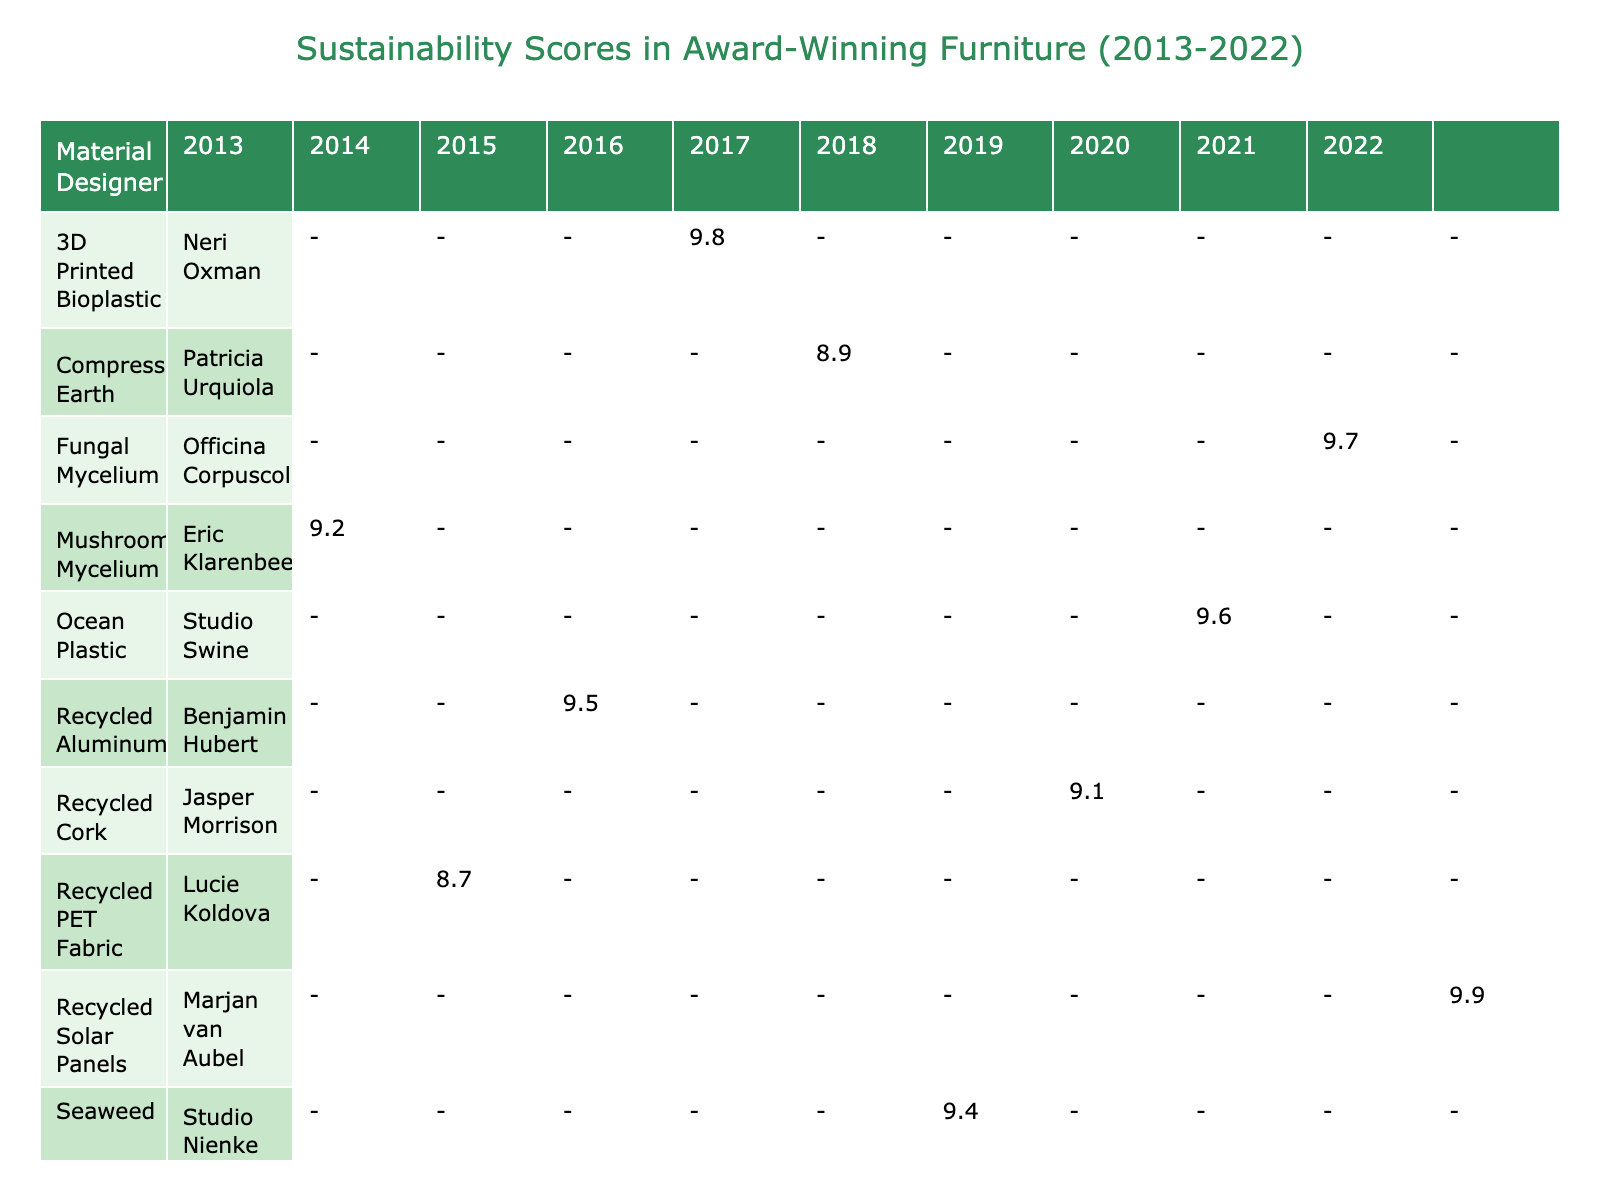What material is associated with the highest sustainability score in 2016? The highest sustainability score in 2016 is 9.8. Looking at the table, the material associated with that score is 3D Printed Bioplastic, designed by Neri Oxman.
Answer: 3D Printed Bioplastic What is the average sustainability score of all furniture pieces from the UK? From the table, the sustainability scores of UK pieces are 9.5 (Zephyr Table) and 9.1 (Cork Lounge Chair). The average is calculated as (9.5 + 9.1) / 2 = 9.3.
Answer: 9.3 Did any furniture piece achieve a sustainability score of 10 or above? No furniture piece in the table has a sustainability score of 10 or above. The highest score is 9.9 for the Solare Bench.
Answer: No Which designer has the most award-winning pieces represented in this table? The table contains one piece from each designer, indicating that there is no designer with multiple award-winning pieces captured.
Answer: Each designer has one piece What is the difference in carbon footprint between the Mycelium Chair and the Algae Lamp? The Mycelium Chair has a carbon footprint of 5.3 kg CO2e, and the Algae Lamp has a footprint of 1.5 kg CO2e. The difference is 5.3 - 1.5 = 3.8 kg CO2e.
Answer: 3.8 kg CO2e Which year had the furniture piece with the longest lifespan, and what was that lifespan? The Solare Bench, designed by Marjan van Aubel in 2022, has the longest lifespan of 30 years based on the table data.
Answer: 2022, 30 years Is there any material that has a recyclability percentage of 100%? Yes, both the Recycled Aluminum (Zephyr Table) and the Recycled Cork (Cork Lounge Chair) have a recyclability percentage of 100%.
Answer: Yes What is the total sustainability score of furniture pieces designed in 2015 and 2020? For 2015, the Zephyr Table has a sustainability score of 9.5, and for 2020, the Reflow Cabinet has a score of 9.6. Adding these gives a total score of 9.5 + 9.6 = 19.1.
Answer: 19.1 